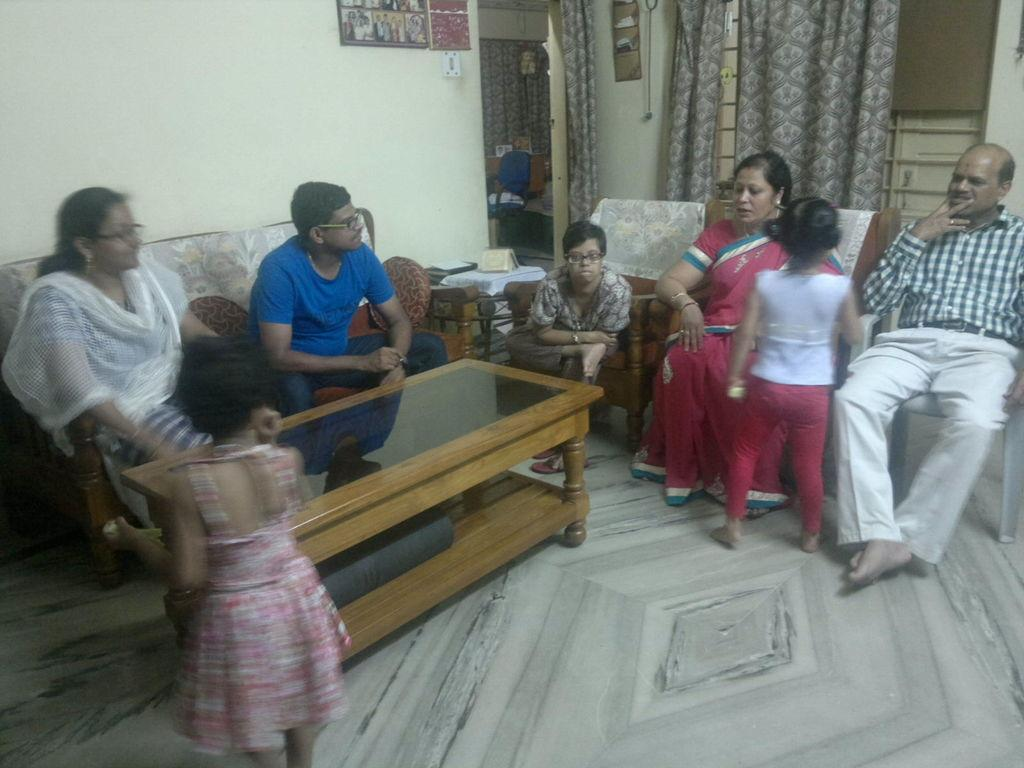What are the people in the image doing? There are people sitting on a sofa in the image. What else can be seen in the image besides the people on the sofa? There are two kids standing in the image. Where is the door located in the image? The door is on the left side of the image. What is present near the window in the background of the image? There is a curtain at a window in the background of the image. What type of cover is being used to control the death of the plants in the image? There are no plants or covers related to controlling death present in the image. 